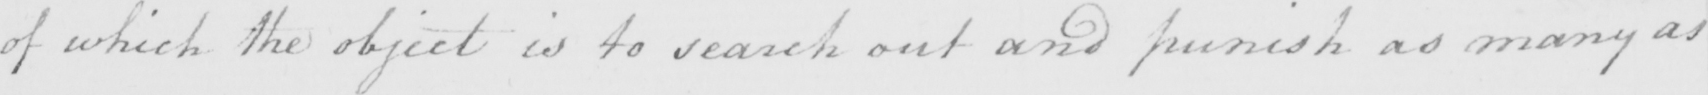Transcribe the text shown in this historical manuscript line. of which the object is to search out and punish as many as 